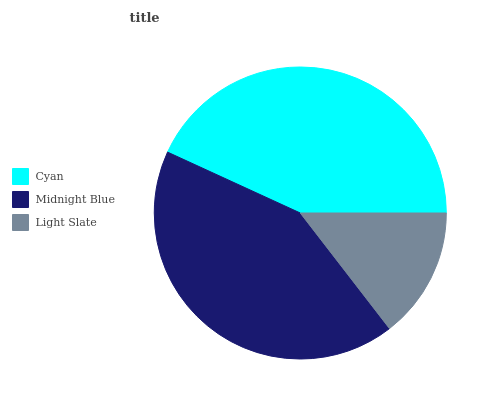Is Light Slate the minimum?
Answer yes or no. Yes. Is Cyan the maximum?
Answer yes or no. Yes. Is Midnight Blue the minimum?
Answer yes or no. No. Is Midnight Blue the maximum?
Answer yes or no. No. Is Cyan greater than Midnight Blue?
Answer yes or no. Yes. Is Midnight Blue less than Cyan?
Answer yes or no. Yes. Is Midnight Blue greater than Cyan?
Answer yes or no. No. Is Cyan less than Midnight Blue?
Answer yes or no. No. Is Midnight Blue the high median?
Answer yes or no. Yes. Is Midnight Blue the low median?
Answer yes or no. Yes. Is Cyan the high median?
Answer yes or no. No. Is Light Slate the low median?
Answer yes or no. No. 